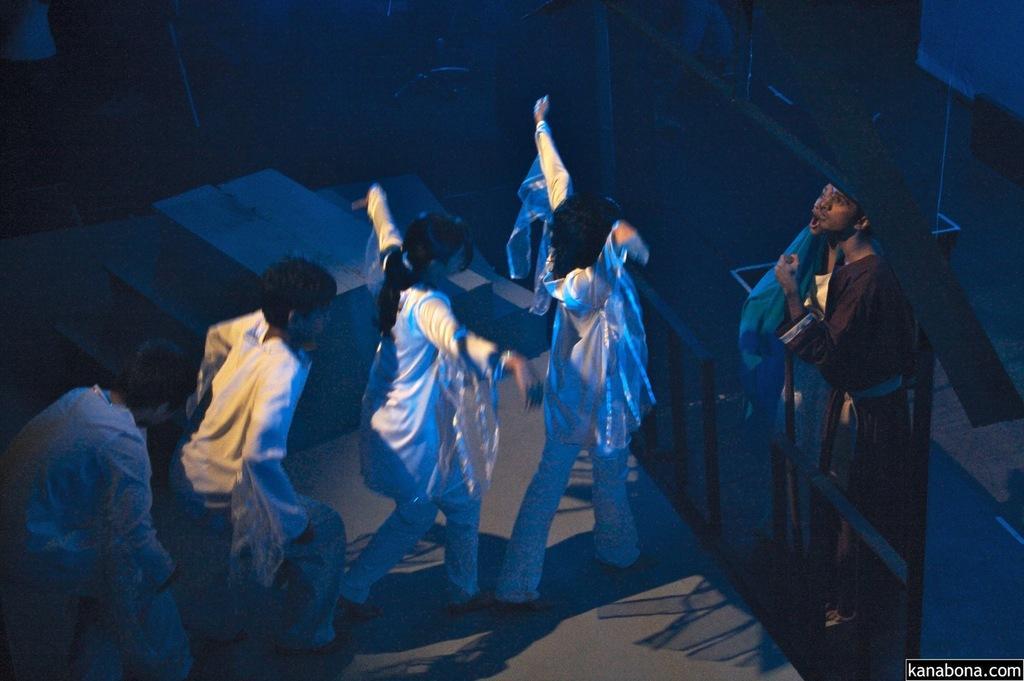Can you describe this image briefly? In this image, we can see few people are performing on the stage. Here we can see stairs, rods, few objects. Right side bottom corner, there is a watermark in the image. 